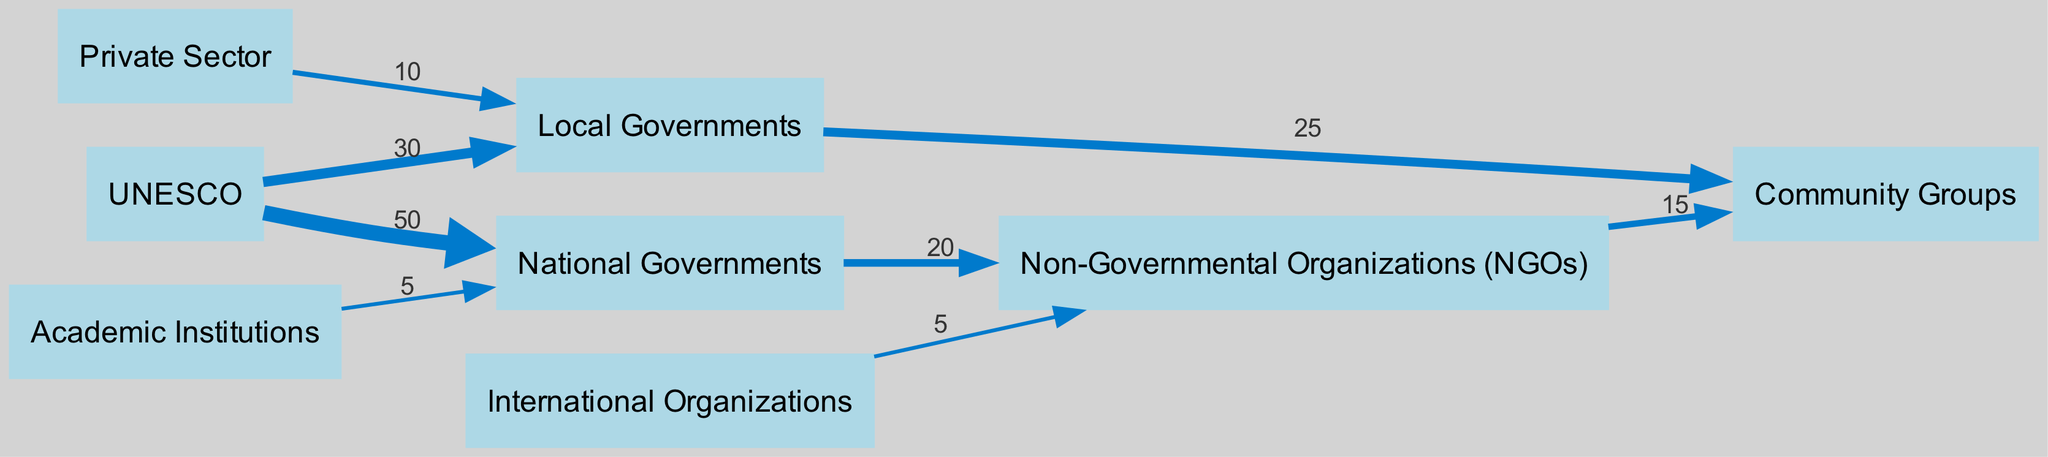What is the total number of nodes in the diagram? The diagram includes each distinct entity listed in the "nodes" section without duplicates. The nodes are UNESCO, Local Governments, National Governments, NGOs, Community Groups, Private Sector, International Organizations, and Academic Institutions, totaling 8 distinct entities.
Answer: 8 What is the value of the link from UNESCO to National Governments? By checking the "links" section, the connection from UNESCO to National Governments shows a value of 50. This value represents the distribution of management responsibilities between these two nodes.
Answer: 50 Which organization has the highest outgoing flow value? Analyzing the flow values, UNESCO has outgoing connections to National Governments (50) and Local Governments (30), giving it a total of 80. In comparison, no other node outflows exceed this total. Therefore, UNESCO has the highest outgoing flow value.
Answer: UNESCO What is the combined value of links from Local Governments to Community Groups? The link from Local Governments to Community Groups has a value of 25. There are no other direct links from Local Governments to Community Groups listed, therefore the combined value remains 25.
Answer: 25 What percentage of UNESCO's outgoing flow is directed towards Local Governments? First, calculate UNESCO's total outgoing flow of 80 (50 to National Governments and 30 to Local Governments). Then, find the percentage towards Local Governments: (30/80) * 100 = 37.5%.
Answer: 37.5% Which node receives contributions from both National Governments and NGOs? Reviewing the links shows that Community Groups are the only node receiving contributions from both National Governments (20 via NGOs) and from Local Governments directly (25).
Answer: Community Groups How many links are directed toward NGOs? The diagram lists links directed toward NGOs from three sources: National Governments (20), International Organizations (5), and UNESCO (0). This results in a total of 3 links directed toward NGOs.
Answer: 3 What is the total incoming flow value to Community Groups? Community Groups receive contributions from two sources: Local Governments (25) and NGOs (15). Adding these two flow values together gives 25 + 15 = 40. Therefore, the total incoming flow value is 40.
Answer: 40 